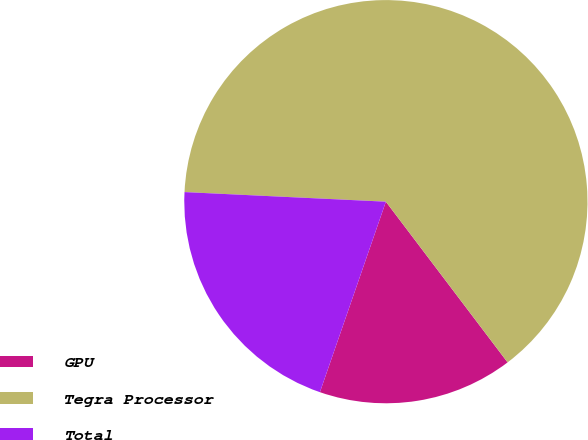Convert chart. <chart><loc_0><loc_0><loc_500><loc_500><pie_chart><fcel>GPU<fcel>Tegra Processor<fcel>Total<nl><fcel>15.62%<fcel>63.92%<fcel>20.45%<nl></chart> 